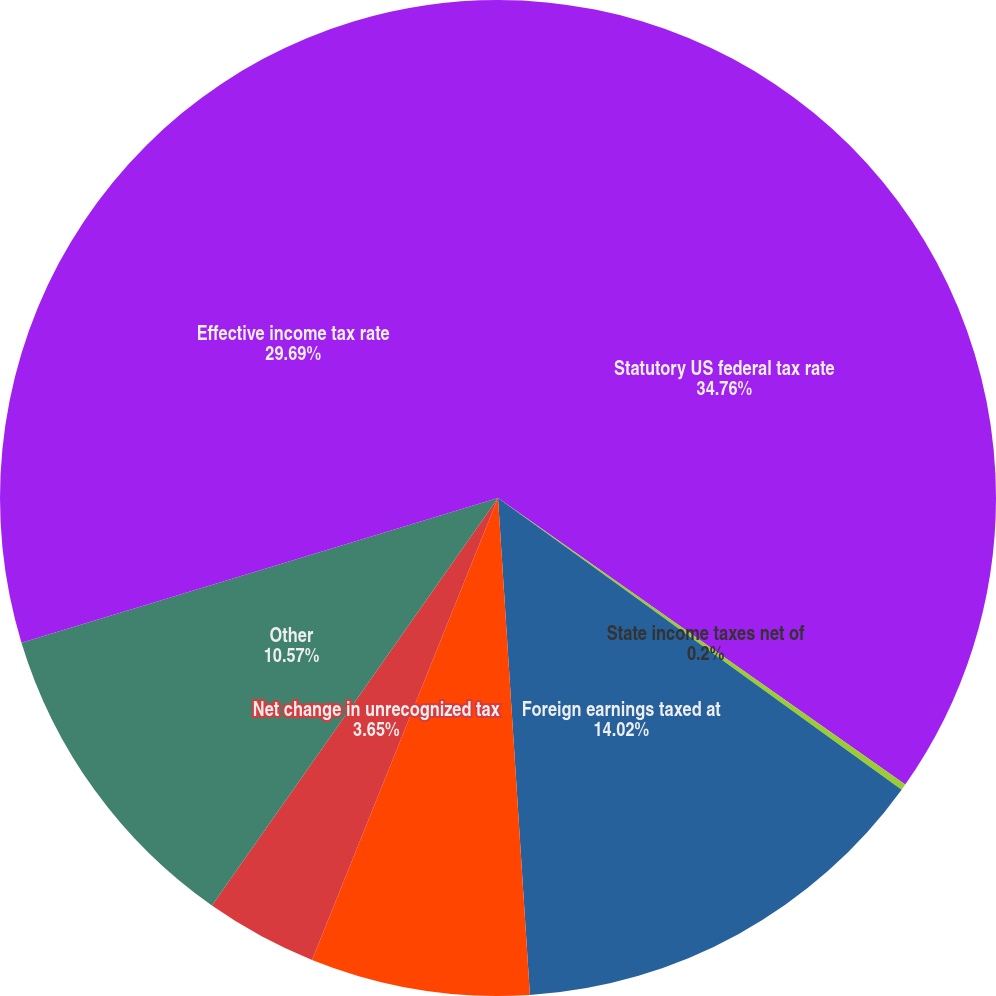<chart> <loc_0><loc_0><loc_500><loc_500><pie_chart><fcel>Statutory US federal tax rate<fcel>State income taxes net of<fcel>Foreign earnings taxed at<fcel>Net change in valuation<fcel>Net change in unrecognized tax<fcel>Other<fcel>Effective income tax rate<nl><fcel>34.76%<fcel>0.2%<fcel>14.02%<fcel>7.11%<fcel>3.65%<fcel>10.57%<fcel>29.69%<nl></chart> 